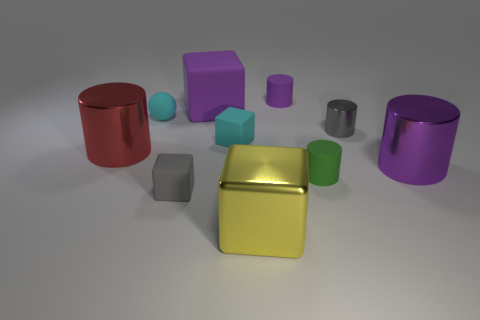Subtract 1 blocks. How many blocks are left? 3 Subtract all large purple shiny cylinders. How many cylinders are left? 4 Subtract all red cylinders. How many cylinders are left? 4 Subtract all yellow cylinders. Subtract all green blocks. How many cylinders are left? 5 Subtract all blocks. How many objects are left? 6 Subtract 0 red spheres. How many objects are left? 10 Subtract all tiny blocks. Subtract all tiny blocks. How many objects are left? 6 Add 6 balls. How many balls are left? 7 Add 7 large brown shiny cubes. How many large brown shiny cubes exist? 7 